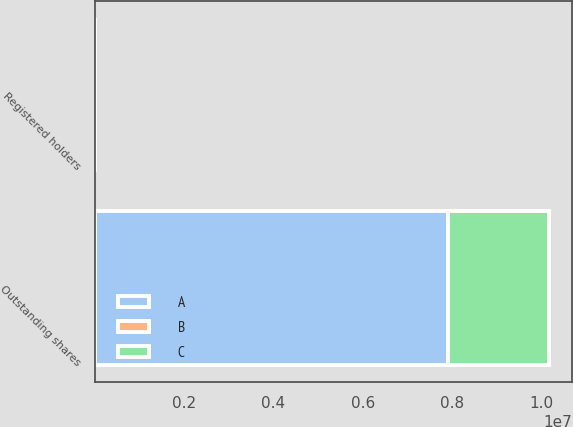Convert chart to OTSL. <chart><loc_0><loc_0><loc_500><loc_500><stacked_bar_chart><ecel><fcel>Outstanding shares<fcel>Registered holders<nl><fcel>B<fcel>893<fcel>893<nl><fcel>A<fcel>7.91707e+06<fcel>58<nl><fcel>C<fcel>2.26781e+06<fcel>1<nl></chart> 